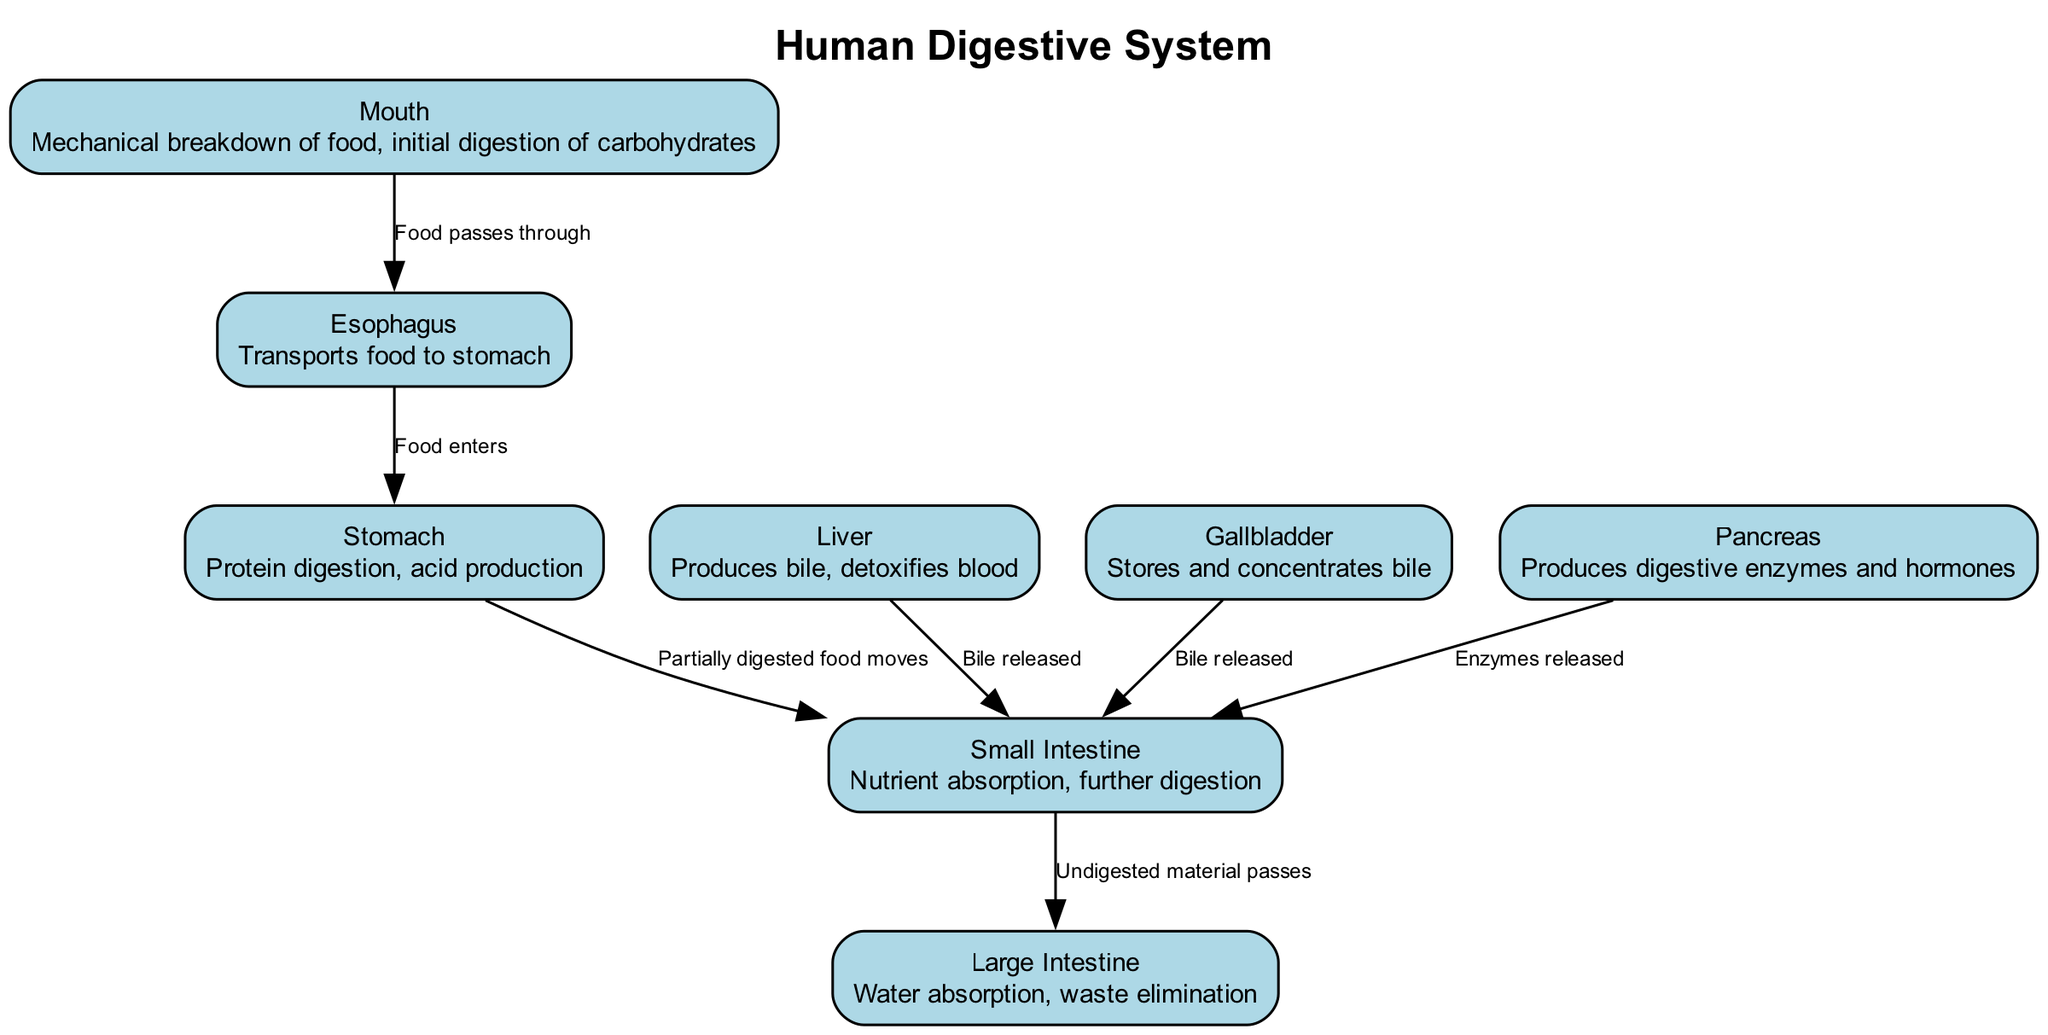What is the function of the stomach? The function of the stomach, as indicated in the diagram, is for protein digestion and acid production. This can be directly found in the labeled section of the stomach's description.
Answer: Protein digestion, acid production How many main components are in the digestive system diagram? To find the number of main components, I count each labeled organ in the diagram. There are a total of eight main components listed.
Answer: 8 What organ releases bile into the small intestine? In the diagram, both the liver and gallbladder are depicted as releasing bile into the small intestine. Thus, I recognize that the gallbladder is directly indicating this action in the connections.
Answer: Liver, Gallbladder What is the connection between the mouth and esophagus? The diagram describes that the connection between the mouth and esophagus is that food passes through from the mouth to the esophagus, specifically indicated in the connections section.
Answer: Food passes through Which organ is responsible for nutrient absorption? The small intestine is labeled in the diagram with the function that describes it as responsible for nutrient absorption, clearly stated in its detailed description.
Answer: Small Intestine What is transported to the stomach via the esophagus? The diagram specifies that food is transported to the stomach via the esophagus, as indicated in the connection description.
Answer: Food What does the pancreas produce? According to the diagram, the pancreas is noted for producing digestive enzymes and hormones, which is detailed under its function in the labeled diagram.
Answer: Digestive enzymes and hormones Which organ comes directly after the stomach in the flow of digestion? By following the connections in the diagram, I see that the small intestine comes directly after the stomach in the digestion pathway, as indicated by the connection description.
Answer: Small Intestine What is the function of the large intestine? The large intestine is described in the diagram as serving the function of water absorption and waste elimination, which can be easily found in its labeled section.
Answer: Water absorption, waste elimination 